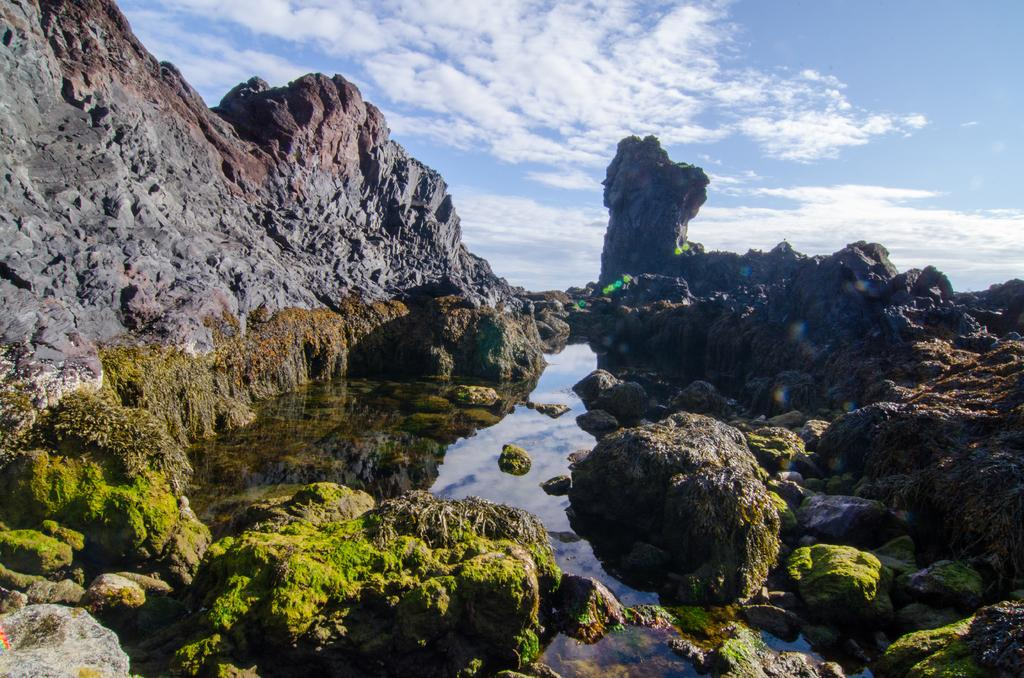What is the primary element in the image? There is water in the image. What other objects or features can be seen in the image? There are rocks in the image. What can be seen in the background of the image? Hills and the sky are visible in the background of the image. Where is the actor sitting on the sofa in the image? There is no actor or sofa present in the image; it features water, rocks, hills, and the sky. 